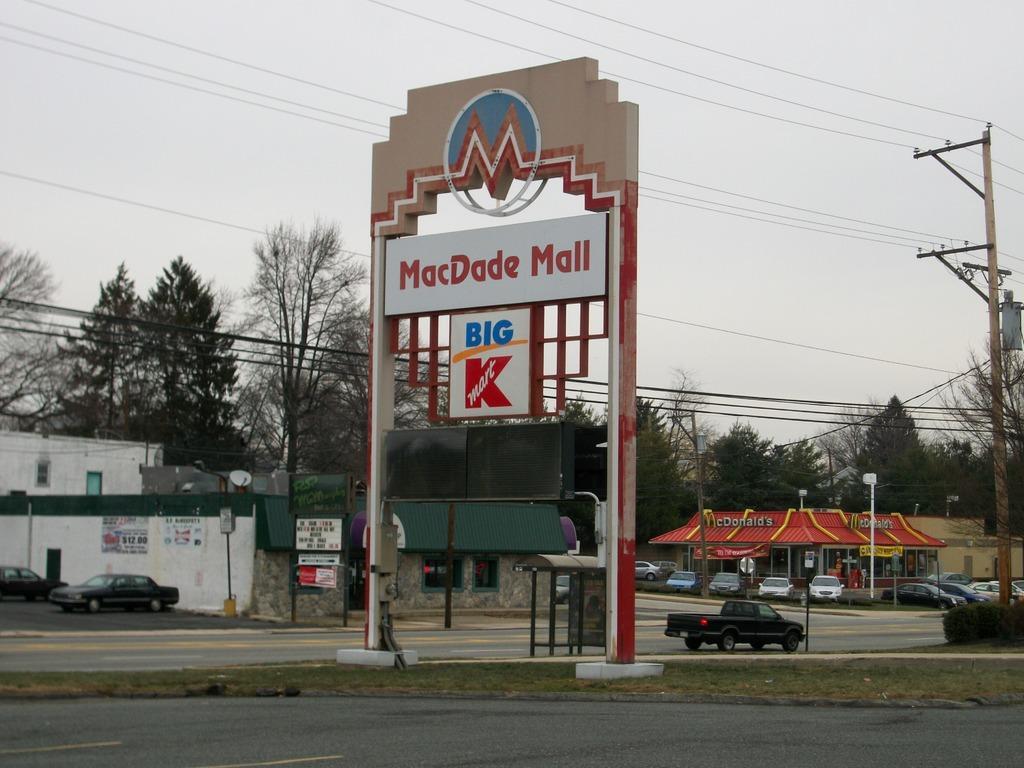How would you summarize this image in a sentence or two? In the foreground of this image, there is the road. In the middle, there is a monument sign. In the background, there are cars, a vehicle moving on the road, few buildings, cars, poles, cables and the sky. 